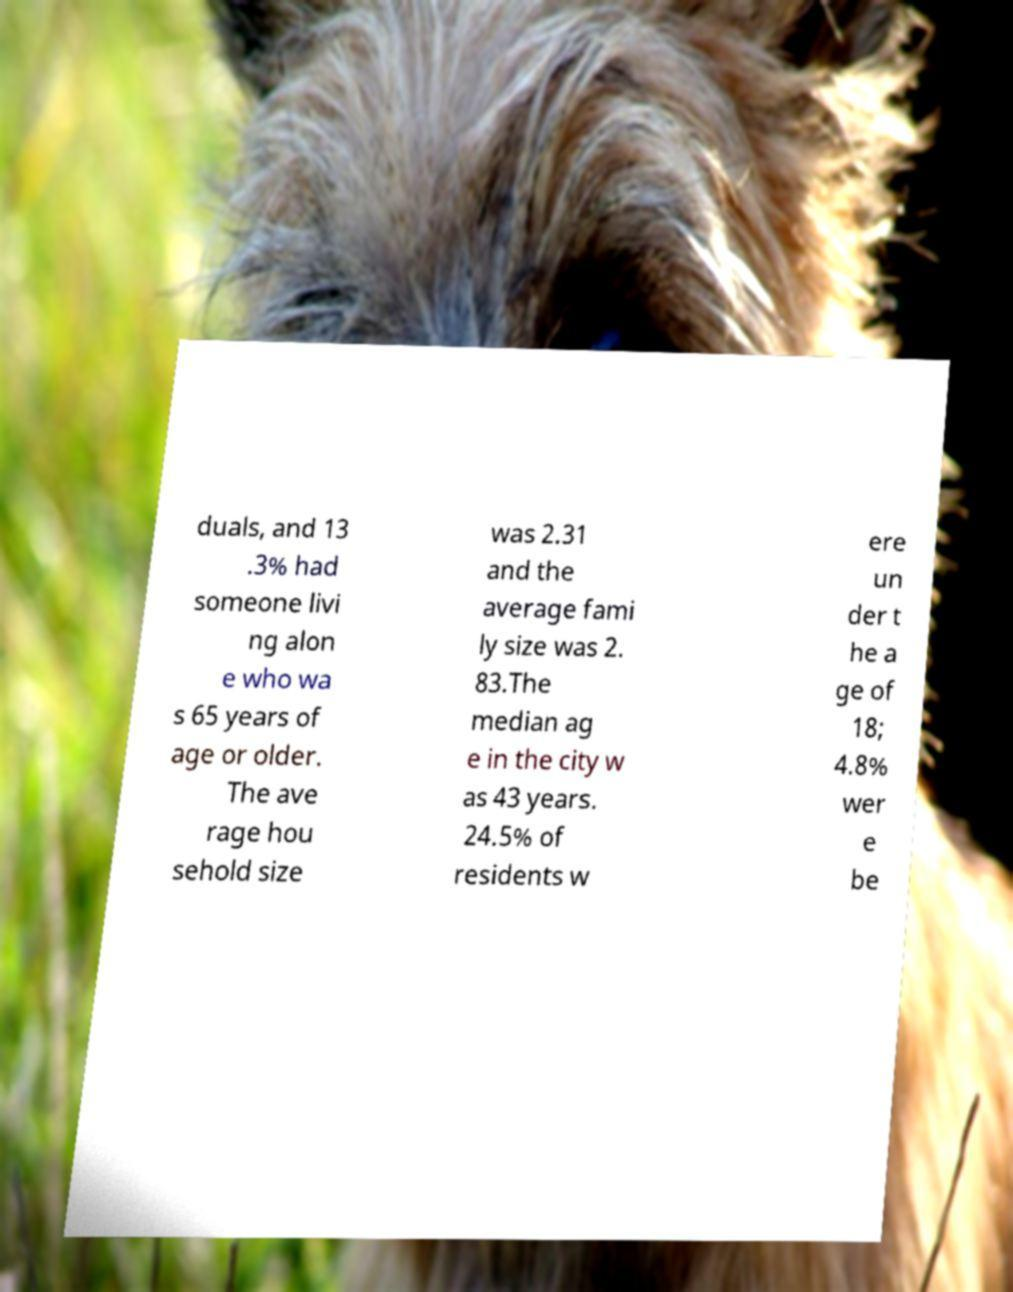I need the written content from this picture converted into text. Can you do that? duals, and 13 .3% had someone livi ng alon e who wa s 65 years of age or older. The ave rage hou sehold size was 2.31 and the average fami ly size was 2. 83.The median ag e in the city w as 43 years. 24.5% of residents w ere un der t he a ge of 18; 4.8% wer e be 